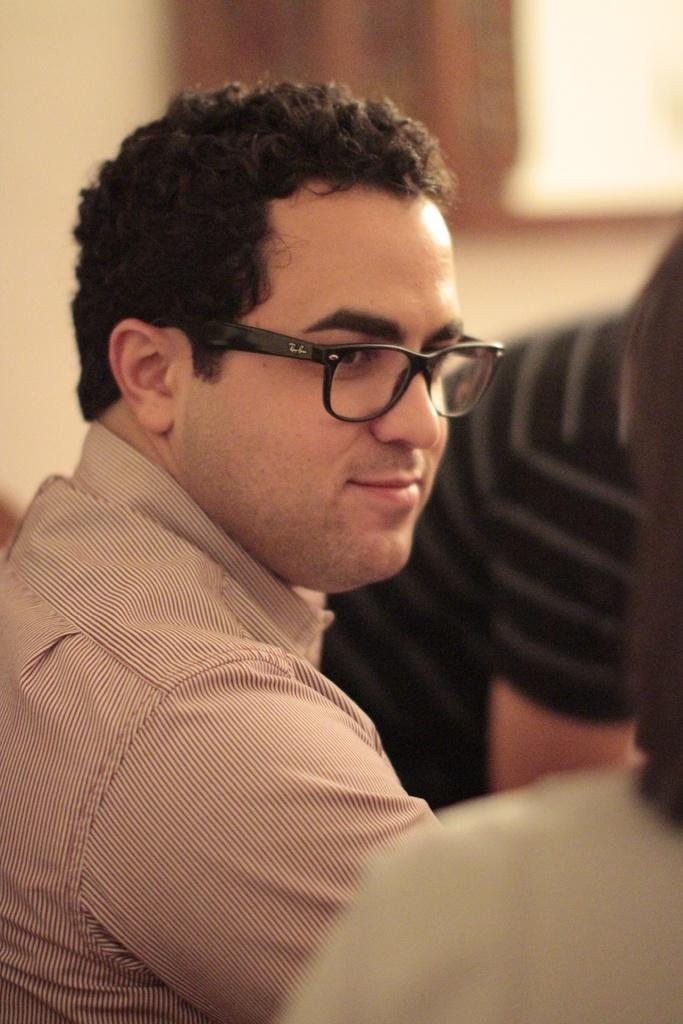How many people are in the image? There are people in the image, but the exact number is not specified. What is the man wearing in the image? The man is wearing a shirt and spectacles in the image. Can you describe the background of the image? The background of the image is blurred. What type of calculator is the man using in the image? There is no calculator present in the image. Can you tell me how many quinces are on the table in the image? There is no table or quinces mentioned in the image. 